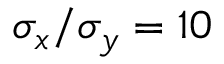Convert formula to latex. <formula><loc_0><loc_0><loc_500><loc_500>\sigma _ { x } / \sigma _ { y } = 1 0</formula> 